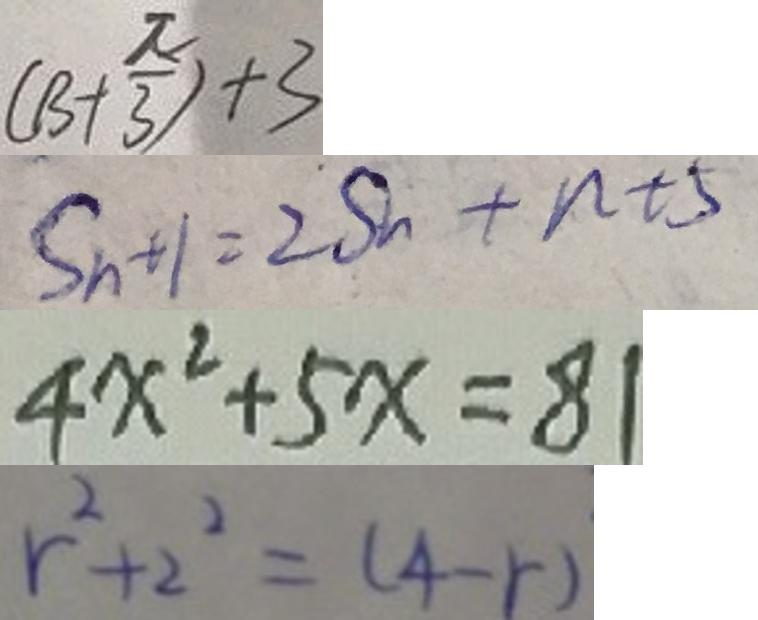Convert formula to latex. <formula><loc_0><loc_0><loc_500><loc_500>( B + \frac { \pi } { 3 } ) + 3 
 S _ { n + 1 } = 2 S _ { n } + n + 5 
 4 x ^ { 2 } + 5 x = 8 1 
 r ^ { 2 } + 2 ^ { 2 } = ( 4 - r )</formula> 